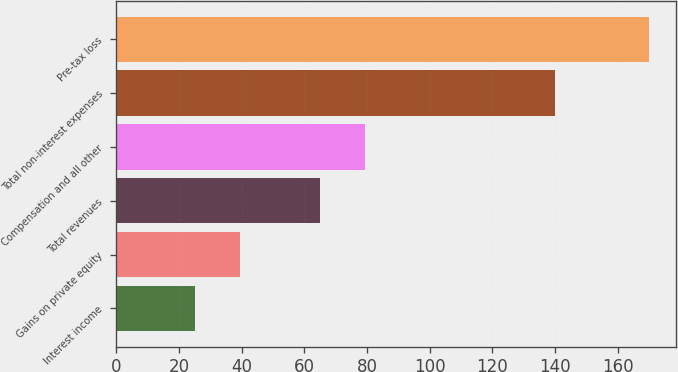Convert chart to OTSL. <chart><loc_0><loc_0><loc_500><loc_500><bar_chart><fcel>Interest income<fcel>Gains on private equity<fcel>Total revenues<fcel>Compensation and all other<fcel>Total non-interest expenses<fcel>Pre-tax loss<nl><fcel>25<fcel>39.5<fcel>65<fcel>79.5<fcel>140<fcel>170<nl></chart> 